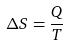<formula> <loc_0><loc_0><loc_500><loc_500>\Delta S = \frac { Q } { T }</formula> 